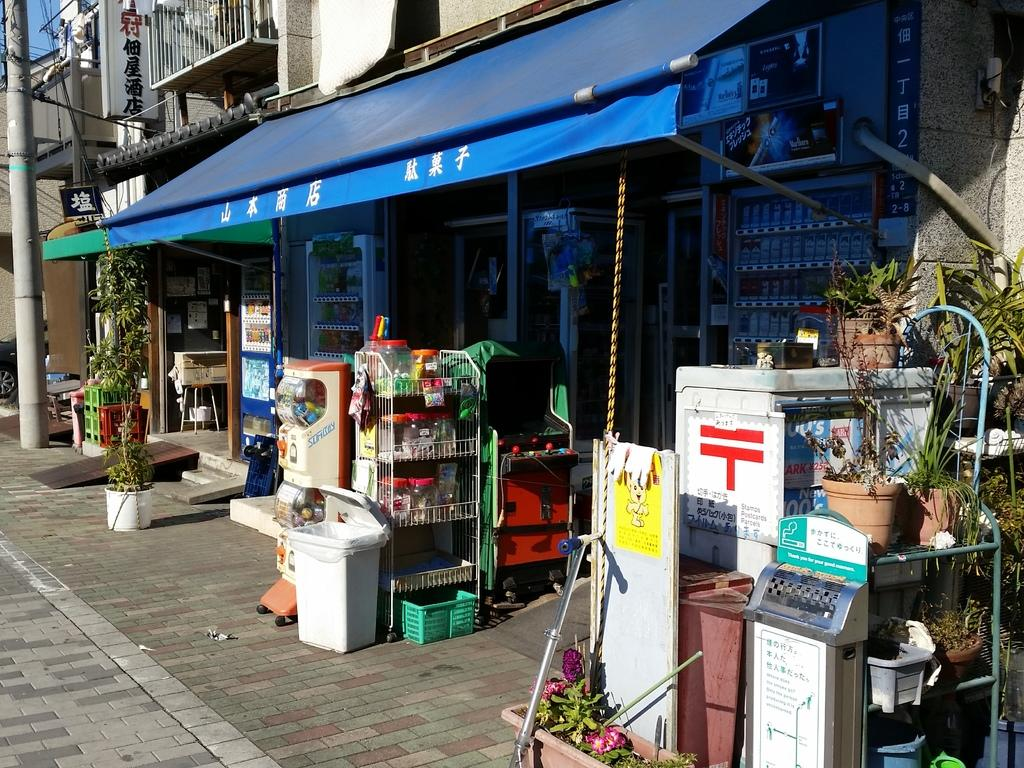<image>
Describe the image concisely. Next to the sign in Chinese is a stamps and postcards parcels 